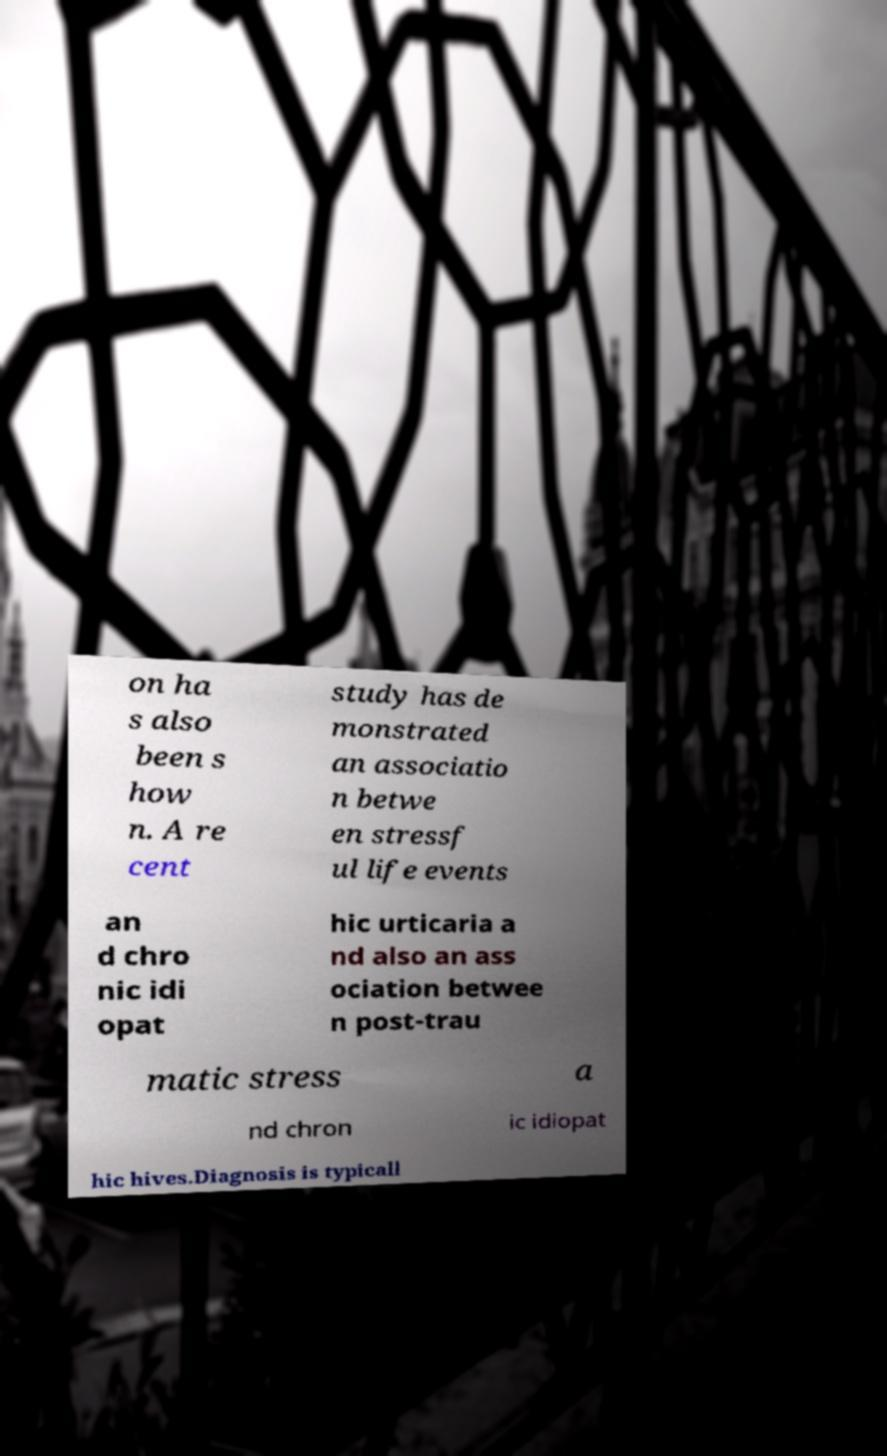Can you accurately transcribe the text from the provided image for me? on ha s also been s how n. A re cent study has de monstrated an associatio n betwe en stressf ul life events an d chro nic idi opat hic urticaria a nd also an ass ociation betwee n post-trau matic stress a nd chron ic idiopat hic hives.Diagnosis is typicall 